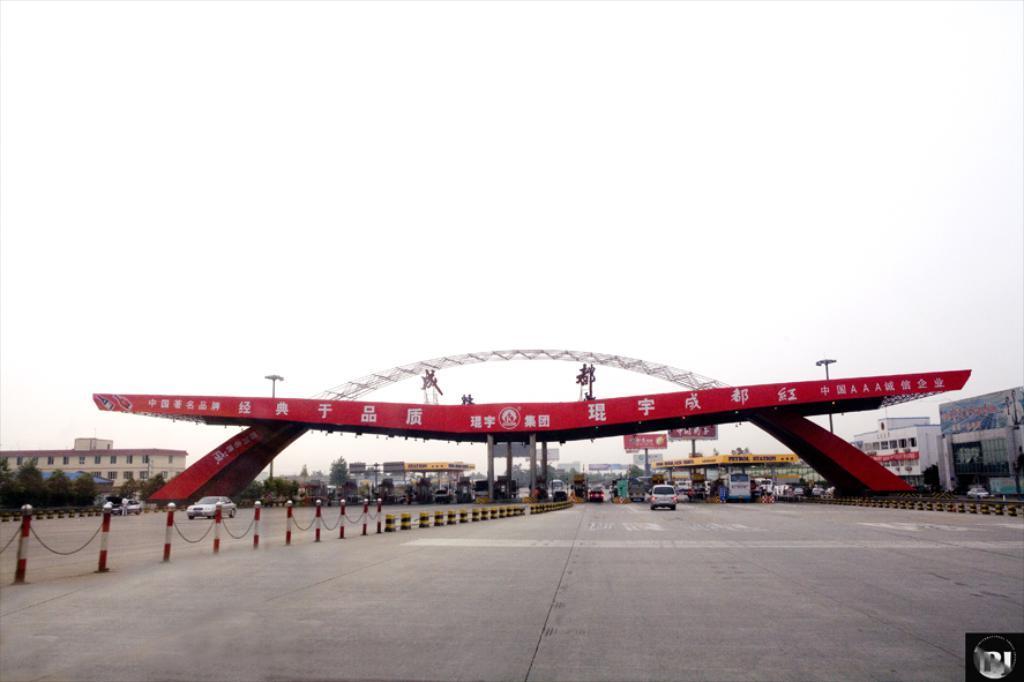Could you give a brief overview of what you see in this image? In the center of the image there is an arch. At the bottom we can see a road and there are vehicles on the road. In the background there are buildings, poles, trees and sky. 